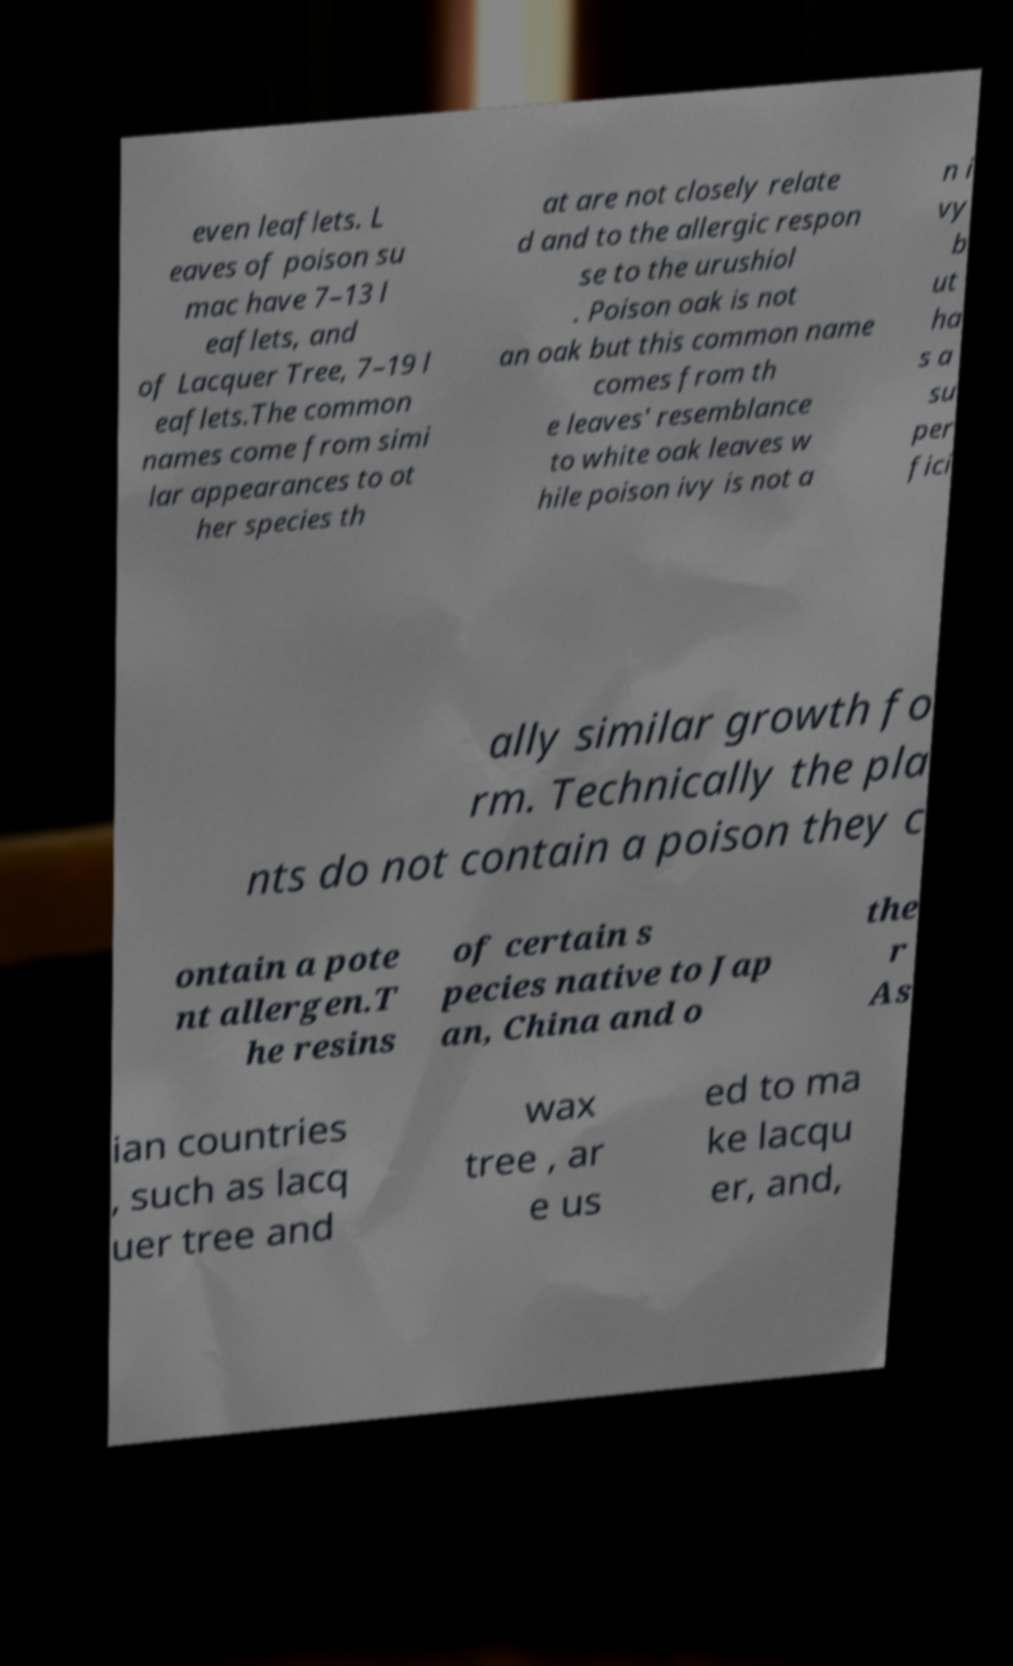Can you read and provide the text displayed in the image?This photo seems to have some interesting text. Can you extract and type it out for me? even leaflets. L eaves of poison su mac have 7–13 l eaflets, and of Lacquer Tree, 7–19 l eaflets.The common names come from simi lar appearances to ot her species th at are not closely relate d and to the allergic respon se to the urushiol . Poison oak is not an oak but this common name comes from th e leaves' resemblance to white oak leaves w hile poison ivy is not a n i vy b ut ha s a su per fici ally similar growth fo rm. Technically the pla nts do not contain a poison they c ontain a pote nt allergen.T he resins of certain s pecies native to Jap an, China and o the r As ian countries , such as lacq uer tree and wax tree , ar e us ed to ma ke lacqu er, and, 